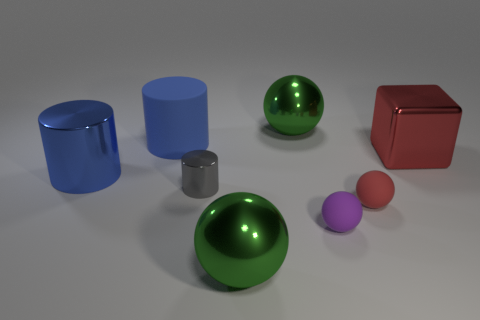Can you tell me what materials the objects might be made from based on their appearance? The objects in the image appear to be made from different materials. The blue cylinder and the red cube have a matte finish that might suggest a plastic or painted wood material. The green and purple spheres have a glossy surface, implying they could be made of a polished metal or plastic with metallic paint. The gray cylinder has a metallic luster, suggesting it might be made of steel or aluminum. 